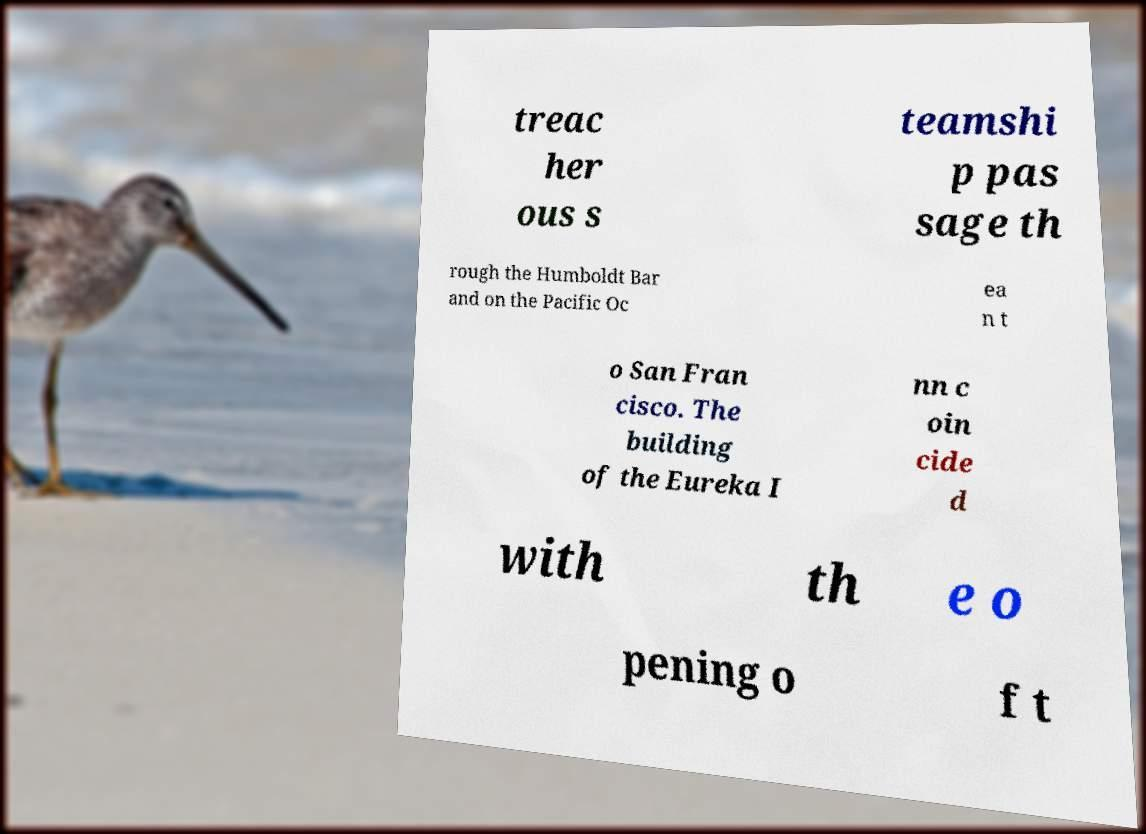Please read and relay the text visible in this image. What does it say? treac her ous s teamshi p pas sage th rough the Humboldt Bar and on the Pacific Oc ea n t o San Fran cisco. The building of the Eureka I nn c oin cide d with th e o pening o f t 